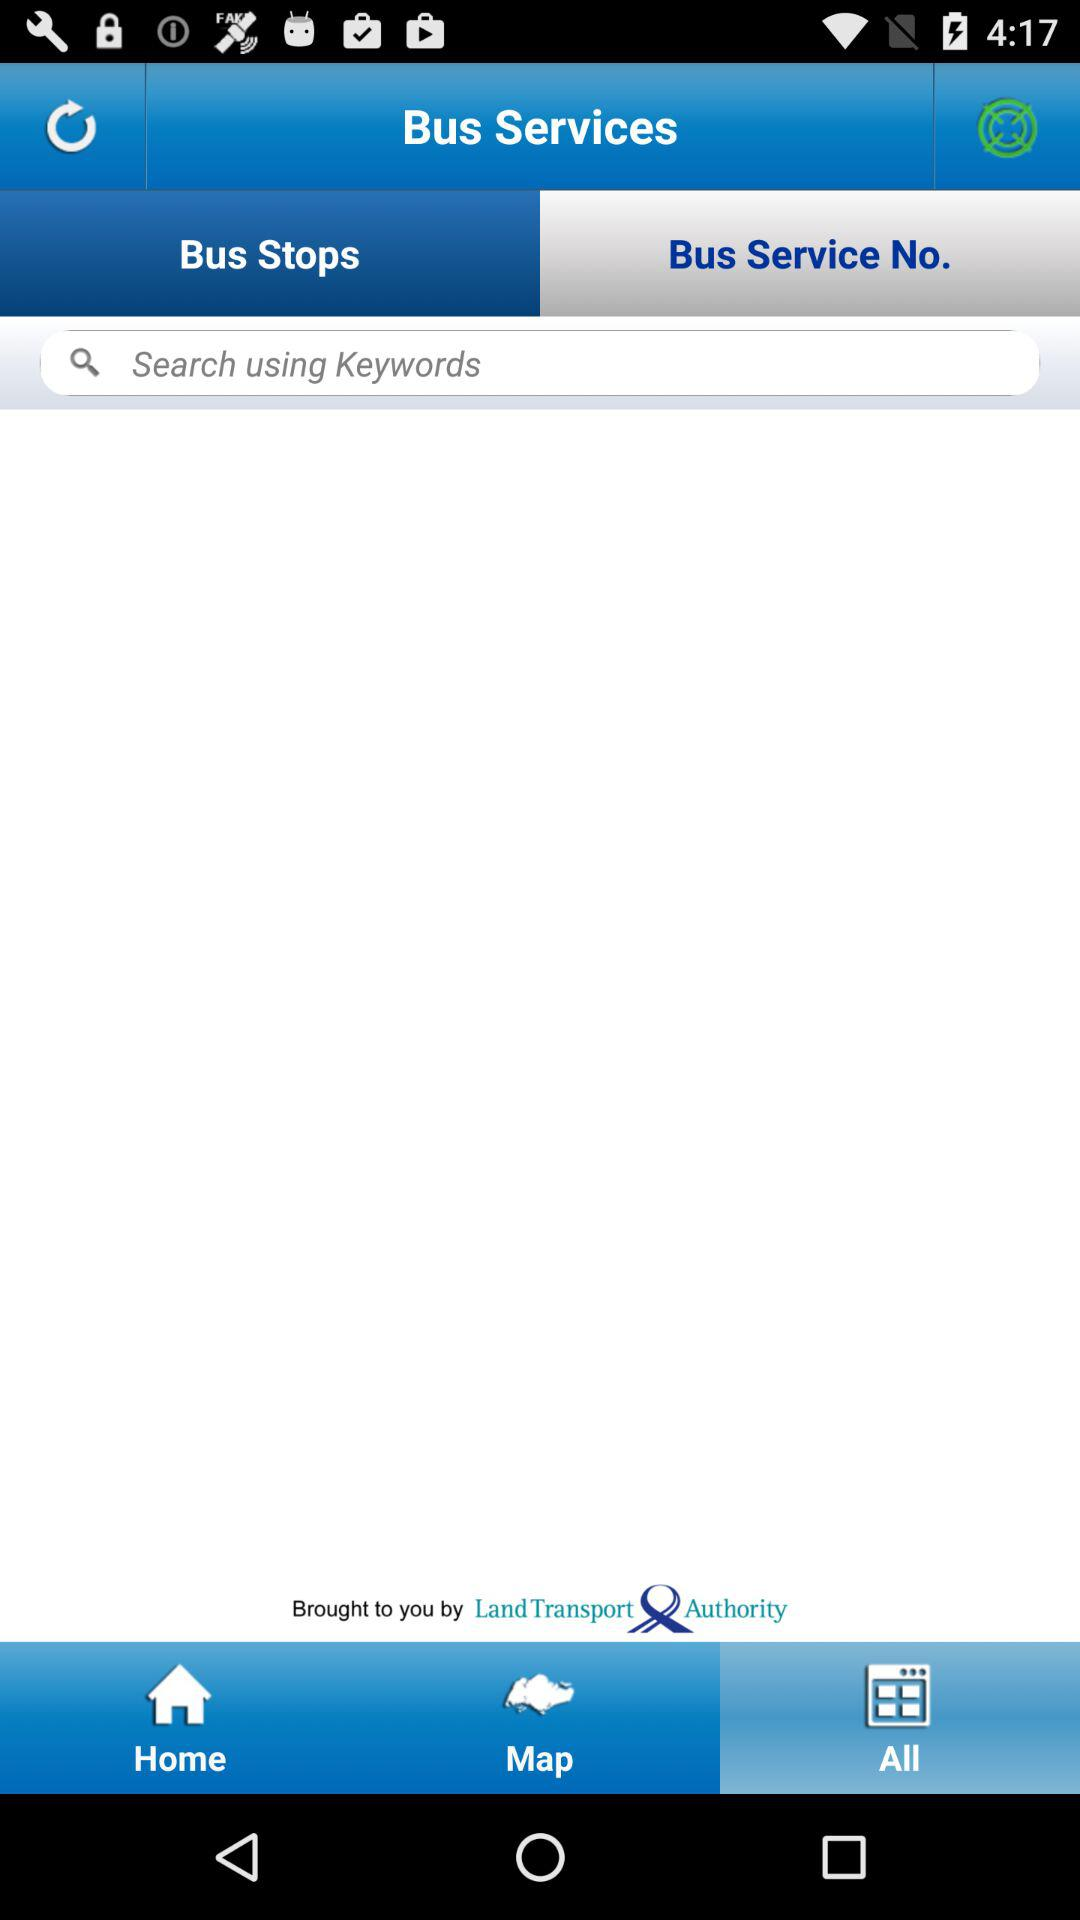Which tab is now selected at the bottom of the page? The selected tab is "All". 